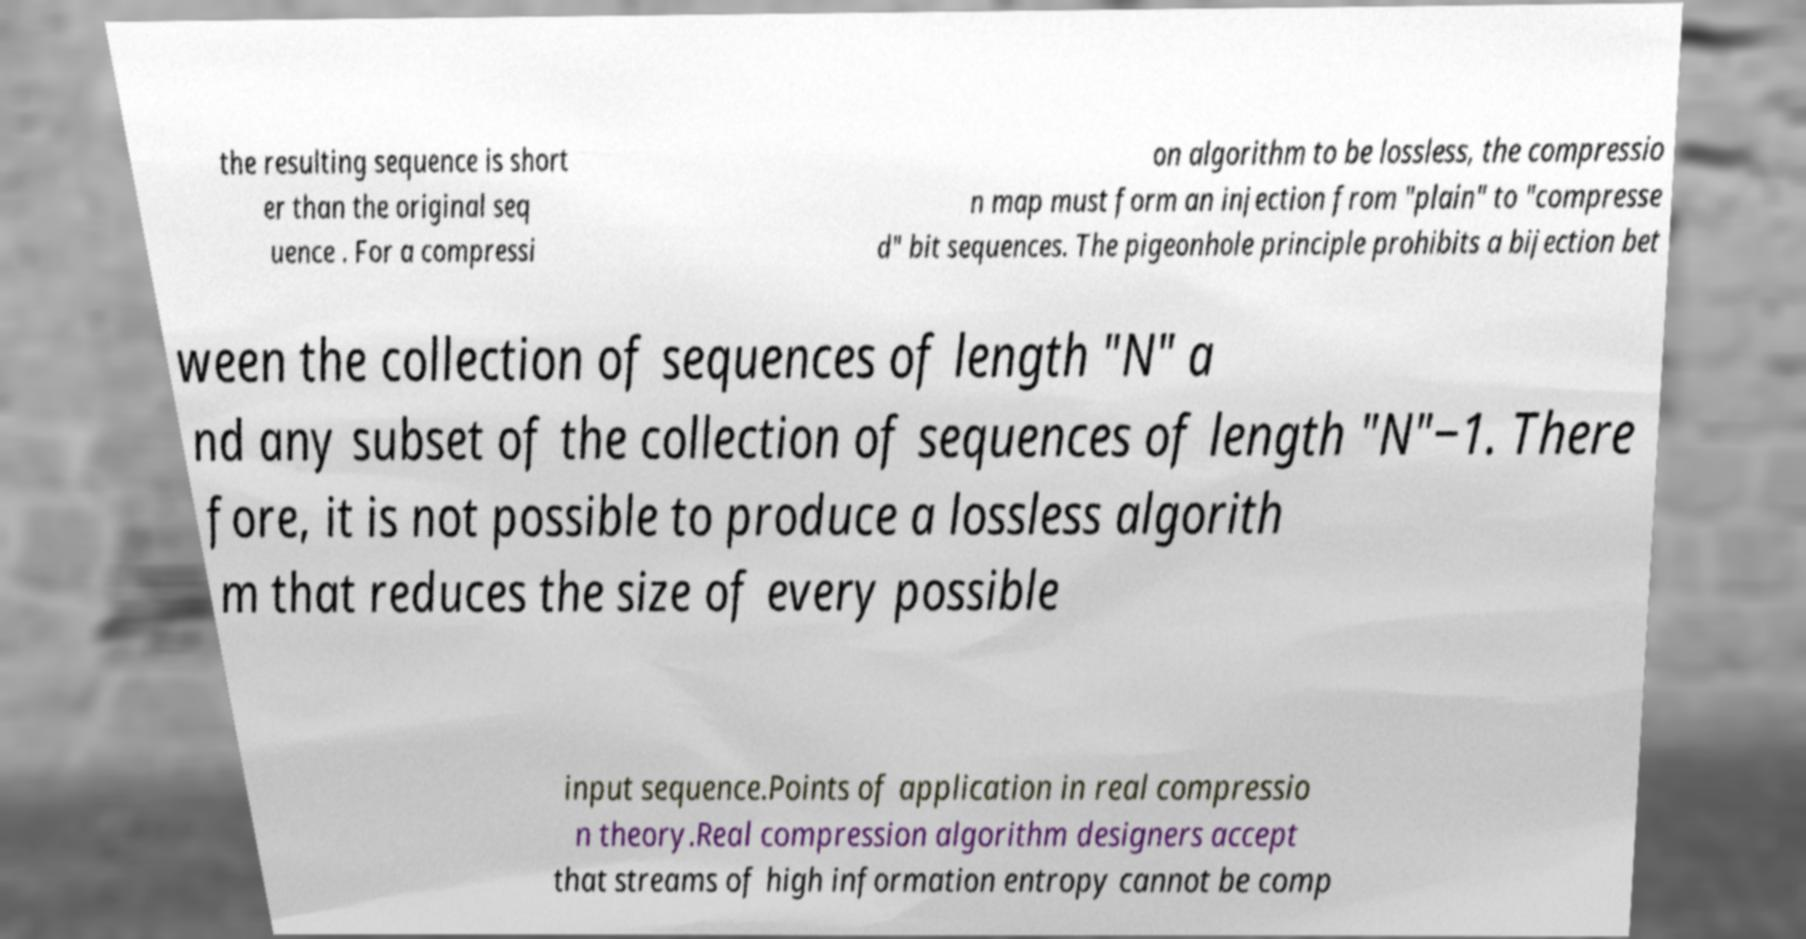Could you assist in decoding the text presented in this image and type it out clearly? the resulting sequence is short er than the original seq uence . For a compressi on algorithm to be lossless, the compressio n map must form an injection from "plain" to "compresse d" bit sequences. The pigeonhole principle prohibits a bijection bet ween the collection of sequences of length "N" a nd any subset of the collection of sequences of length "N"−1. There fore, it is not possible to produce a lossless algorith m that reduces the size of every possible input sequence.Points of application in real compressio n theory.Real compression algorithm designers accept that streams of high information entropy cannot be comp 